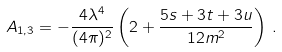Convert formula to latex. <formula><loc_0><loc_0><loc_500><loc_500>A _ { 1 , 3 } = - \frac { 4 \lambda ^ { 4 } } { ( 4 \pi ) ^ { 2 } } \left ( 2 + \frac { 5 s + 3 t + 3 u } { 1 2 m ^ { 2 } } \right ) \, . \\</formula> 